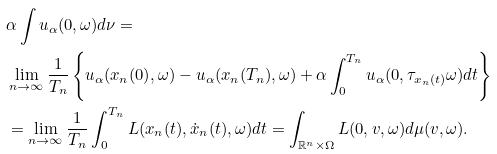Convert formula to latex. <formula><loc_0><loc_0><loc_500><loc_500>& \alpha \int u _ { \alpha } ( 0 , \omega ) d \nu = \\ & \lim _ { n \to \infty } \frac { 1 } { T _ { n } } \left \{ u _ { \alpha } ( x _ { n } ( 0 ) , \omega ) - u _ { \alpha } ( x _ { n } ( T _ { n } ) , \omega ) + \alpha \int _ { 0 } ^ { T _ { n } } u _ { \alpha } ( 0 , \tau _ { x _ { n } ( t ) } \omega ) d t \right \} \\ & = \lim _ { n \to \infty } \frac { 1 } { T _ { n } } \int _ { 0 } ^ { T _ { n } } L ( x _ { n } ( t ) , \dot { x } _ { n } ( t ) , \omega ) d t = \int _ { \mathbb { R } ^ { n } \times \Omega } L ( 0 , v , \omega ) d \mu ( v , \omega ) .</formula> 